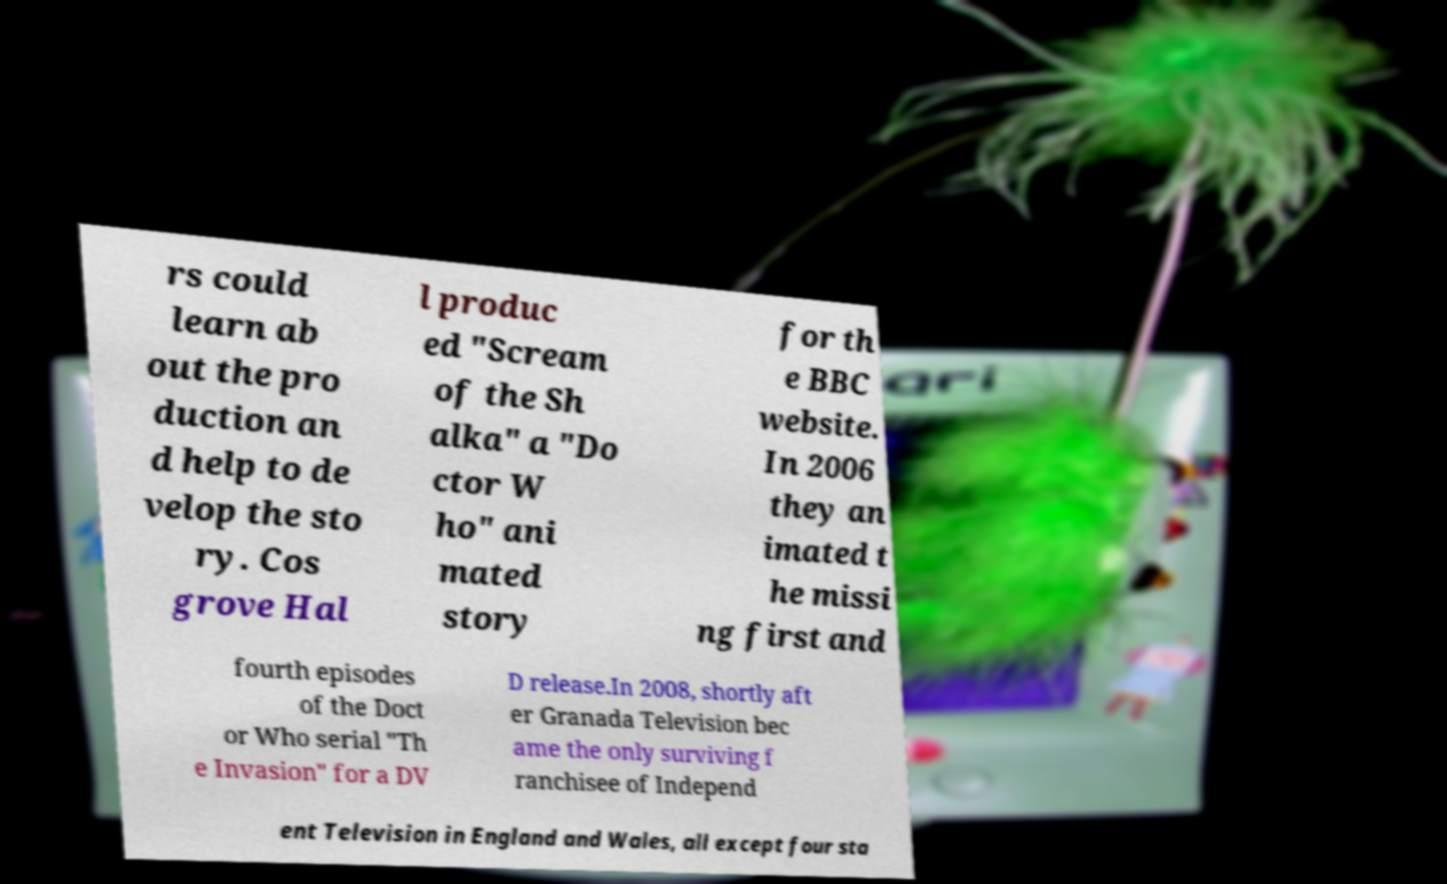Can you accurately transcribe the text from the provided image for me? rs could learn ab out the pro duction an d help to de velop the sto ry. Cos grove Hal l produc ed "Scream of the Sh alka" a "Do ctor W ho" ani mated story for th e BBC website. In 2006 they an imated t he missi ng first and fourth episodes of the Doct or Who serial "Th e Invasion" for a DV D release.In 2008, shortly aft er Granada Television bec ame the only surviving f ranchisee of Independ ent Television in England and Wales, all except four sta 